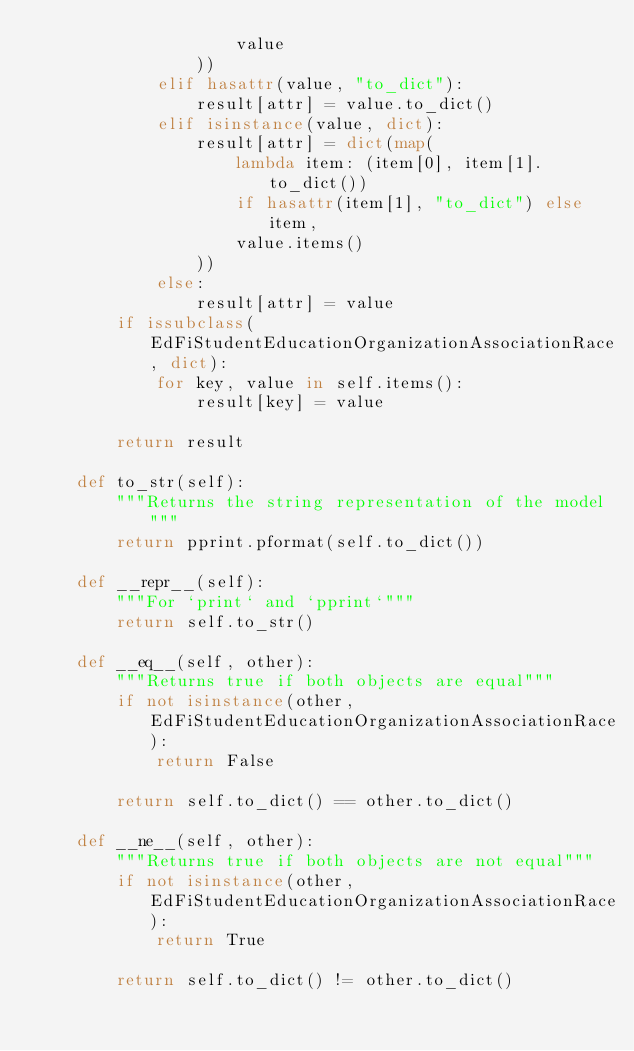<code> <loc_0><loc_0><loc_500><loc_500><_Python_>                    value
                ))
            elif hasattr(value, "to_dict"):
                result[attr] = value.to_dict()
            elif isinstance(value, dict):
                result[attr] = dict(map(
                    lambda item: (item[0], item[1].to_dict())
                    if hasattr(item[1], "to_dict") else item,
                    value.items()
                ))
            else:
                result[attr] = value
        if issubclass(EdFiStudentEducationOrganizationAssociationRace, dict):
            for key, value in self.items():
                result[key] = value

        return result

    def to_str(self):
        """Returns the string representation of the model"""
        return pprint.pformat(self.to_dict())

    def __repr__(self):
        """For `print` and `pprint`"""
        return self.to_str()

    def __eq__(self, other):
        """Returns true if both objects are equal"""
        if not isinstance(other, EdFiStudentEducationOrganizationAssociationRace):
            return False

        return self.to_dict() == other.to_dict()

    def __ne__(self, other):
        """Returns true if both objects are not equal"""
        if not isinstance(other, EdFiStudentEducationOrganizationAssociationRace):
            return True

        return self.to_dict() != other.to_dict()
</code> 